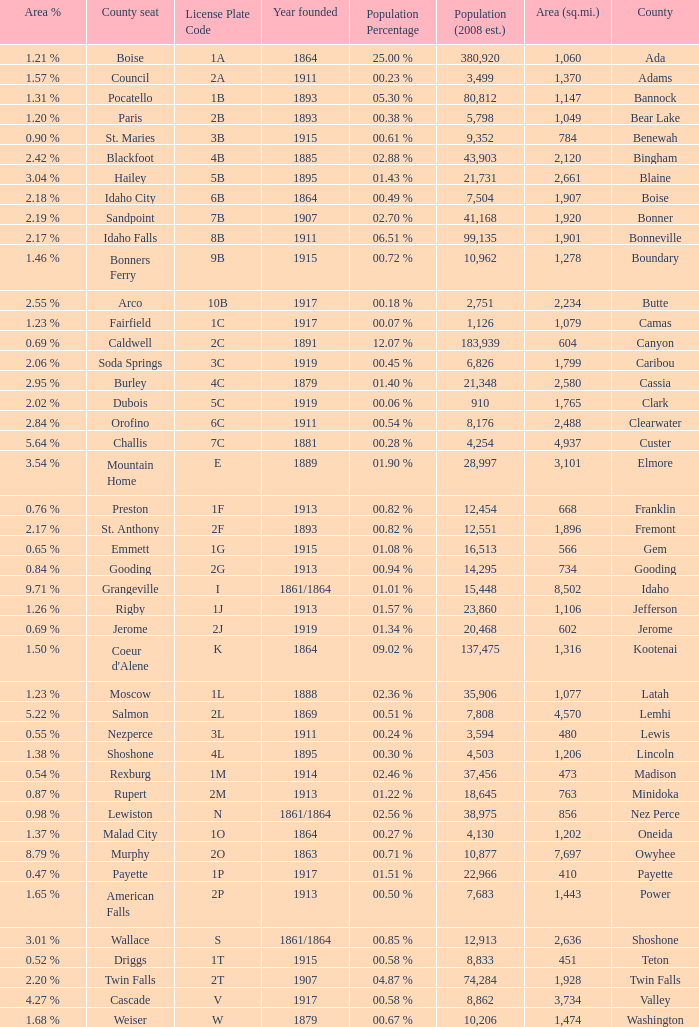What is the country seat for the license plate code 5c? Dubois. 